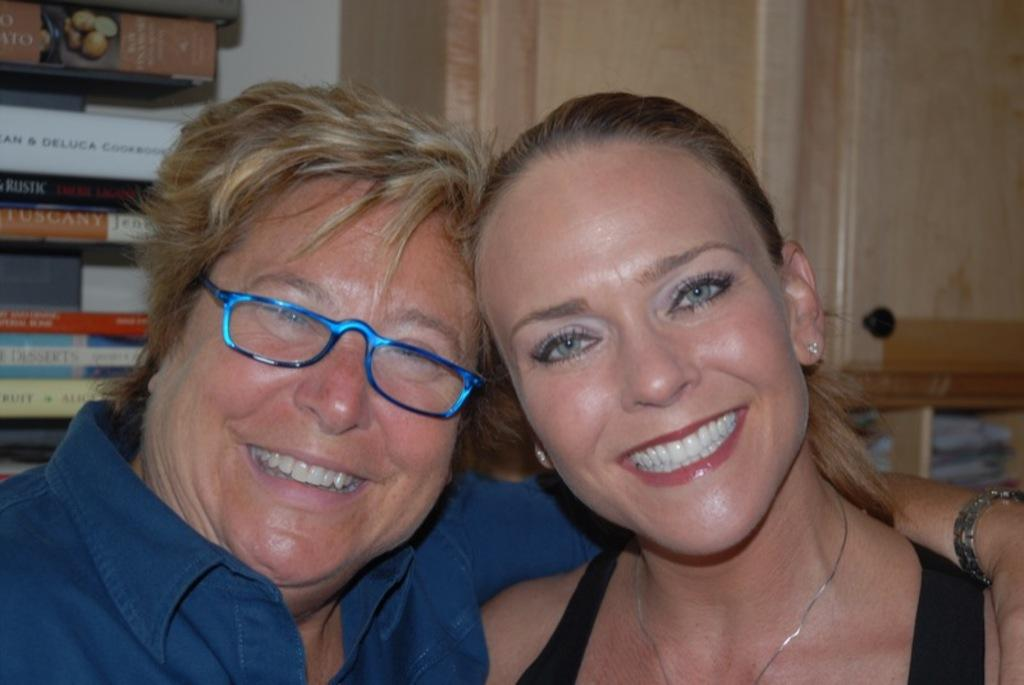How many people are in the image? There are two women in the image. What is the facial expression of the women in the image? The women are smiling. What can be seen on the left side of the image? There is a bookshelf on the left side of the image. What type of heat source can be seen in the image? There is no heat source present in the image. Can you tell me when the birth of the women in the image took place? The image does not provide any information about the birth of the women. 